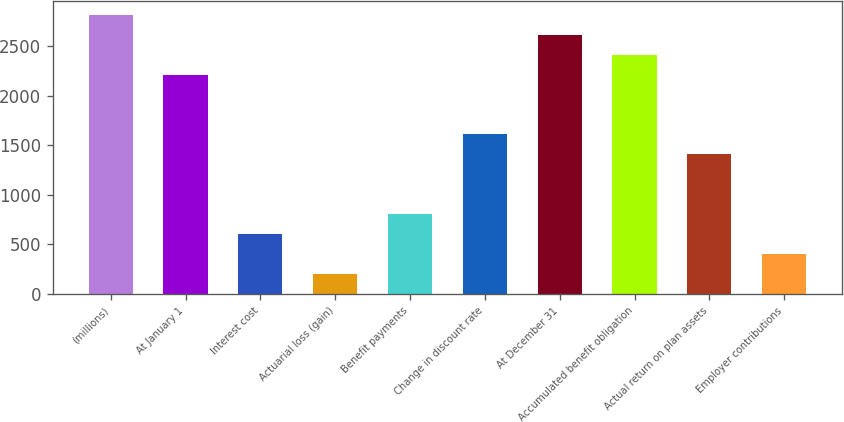Convert chart to OTSL. <chart><loc_0><loc_0><loc_500><loc_500><bar_chart><fcel>(millions)<fcel>At January 1<fcel>Interest cost<fcel>Actuarial loss (gain)<fcel>Benefit payments<fcel>Change in discount rate<fcel>At December 31<fcel>Accumulated benefit obligation<fcel>Actual return on plan assets<fcel>Employer contributions<nl><fcel>2818.4<fcel>2215.1<fcel>606.3<fcel>204.1<fcel>807.4<fcel>1611.8<fcel>2617.3<fcel>2416.2<fcel>1410.7<fcel>405.2<nl></chart> 